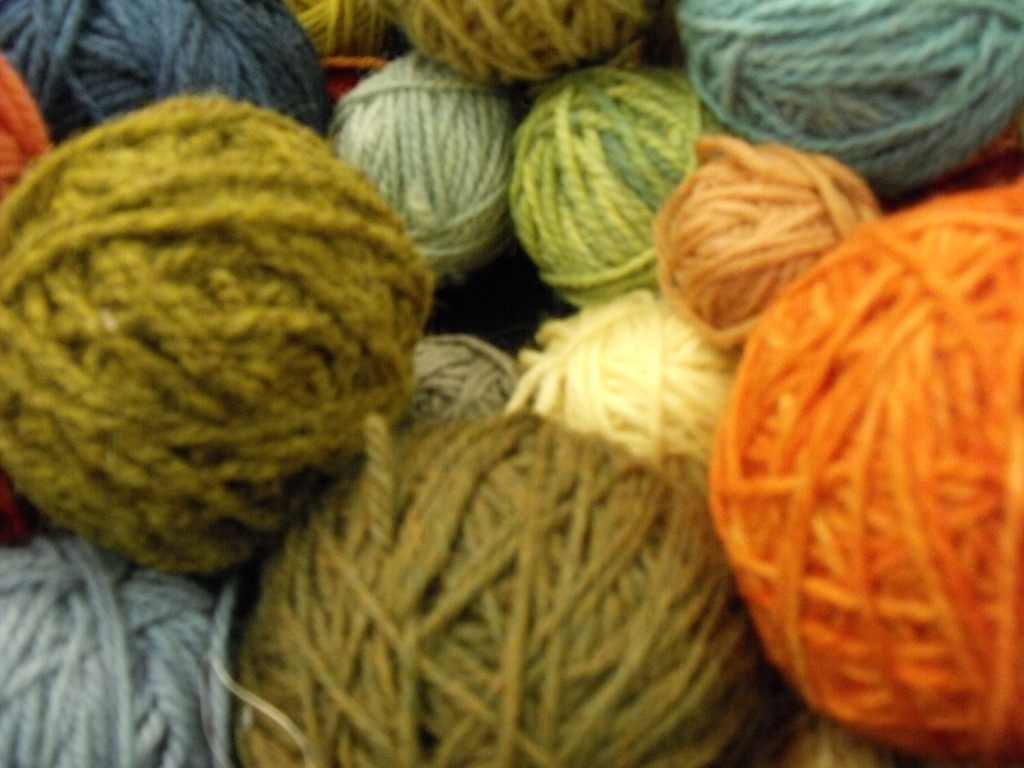What can you tell me about the objects in this image? The image features a collection of yarn balls of various colors. These balls of yarn could be used for knitting, crocheting, or other craft projects. The range of colors suggests the possibility of creating multi-colored textiles or garments with a creative and personalized touch. 